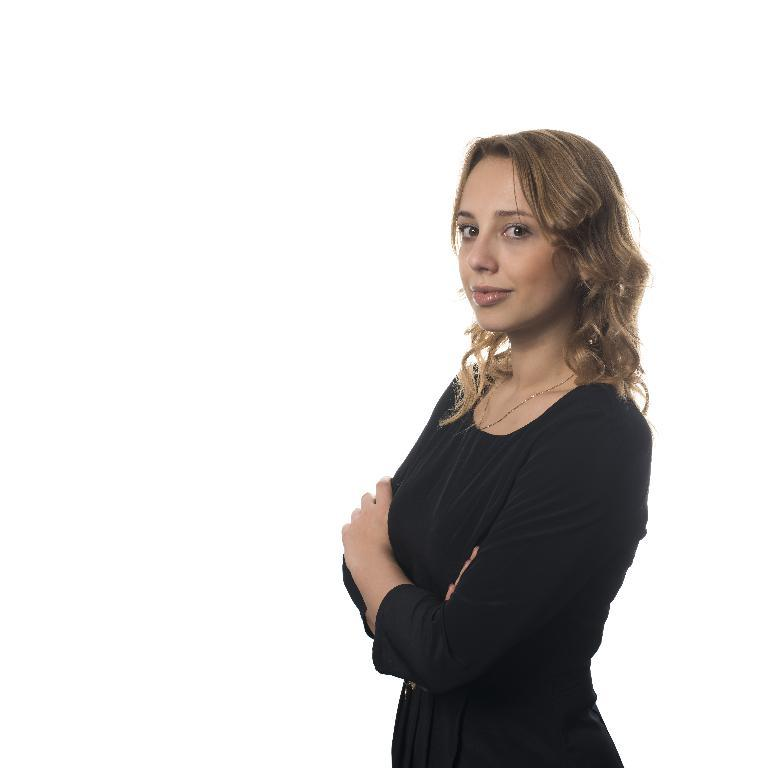What is the main subject of the image? There is a woman in the image. What is the woman doing in the image? The woman is standing in the image. Where is the woman located in the image? The woman is in the center of the image. What color is the sweater the woman is wearing in the image? There is no information about the woman's clothing in the provided facts, so we cannot determine the color of her sweater. How long has the woman been a beginner at standing in the image? The woman is not described as a beginner at standing in the image, so we cannot determine how long she has been practicing. 